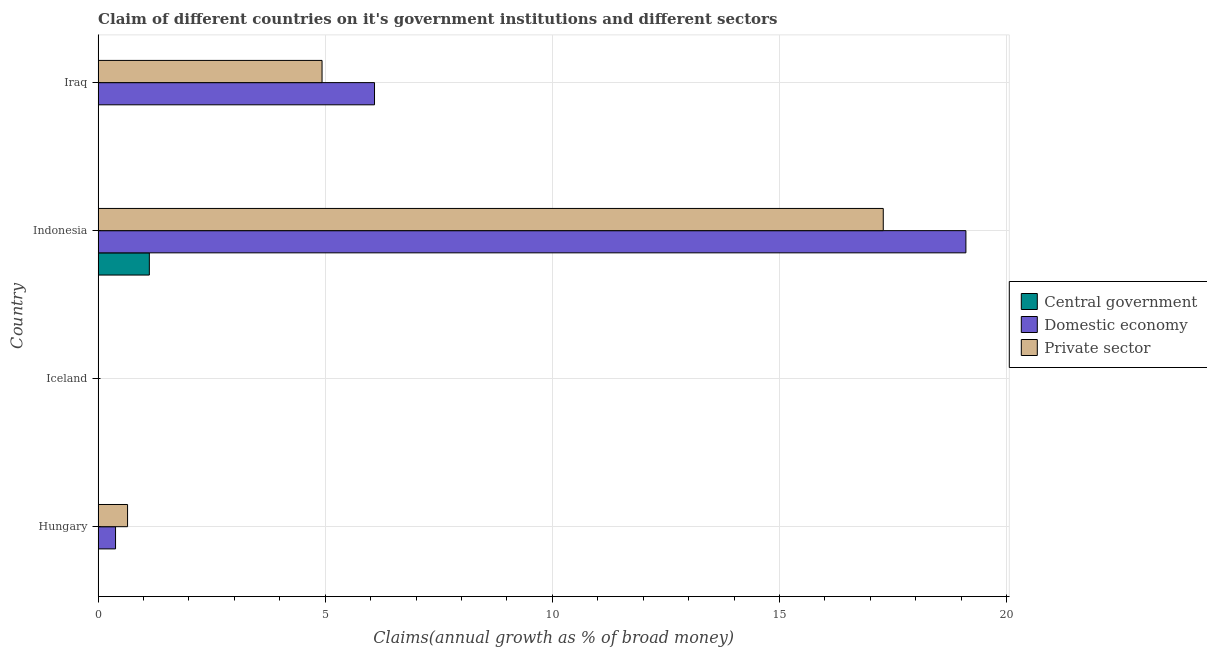Are the number of bars on each tick of the Y-axis equal?
Give a very brief answer. No. How many bars are there on the 4th tick from the top?
Make the answer very short. 2. How many bars are there on the 1st tick from the bottom?
Your answer should be very brief. 2. What is the label of the 4th group of bars from the top?
Keep it short and to the point. Hungary. Across all countries, what is the maximum percentage of claim on the central government?
Provide a short and direct response. 1.13. Across all countries, what is the minimum percentage of claim on the domestic economy?
Ensure brevity in your answer.  0. In which country was the percentage of claim on the private sector maximum?
Make the answer very short. Indonesia. What is the total percentage of claim on the domestic economy in the graph?
Your answer should be very brief. 25.57. What is the difference between the percentage of claim on the domestic economy in Hungary and that in Indonesia?
Your answer should be compact. -18.72. What is the average percentage of claim on the domestic economy per country?
Your response must be concise. 6.39. What is the difference between the percentage of claim on the central government and percentage of claim on the domestic economy in Indonesia?
Offer a terse response. -17.98. What is the ratio of the percentage of claim on the domestic economy in Indonesia to that in Iraq?
Offer a very short reply. 3.14. Is the percentage of claim on the domestic economy in Hungary less than that in Iraq?
Your answer should be very brief. Yes. What is the difference between the highest and the second highest percentage of claim on the private sector?
Offer a very short reply. 12.36. Is the sum of the percentage of claim on the domestic economy in Indonesia and Iraq greater than the maximum percentage of claim on the central government across all countries?
Provide a succinct answer. Yes. How many bars are there?
Your response must be concise. 7. Are all the bars in the graph horizontal?
Keep it short and to the point. Yes. How many countries are there in the graph?
Offer a very short reply. 4. Are the values on the major ticks of X-axis written in scientific E-notation?
Your answer should be very brief. No. How are the legend labels stacked?
Offer a terse response. Vertical. What is the title of the graph?
Offer a terse response. Claim of different countries on it's government institutions and different sectors. What is the label or title of the X-axis?
Your answer should be compact. Claims(annual growth as % of broad money). What is the Claims(annual growth as % of broad money) of Central government in Hungary?
Make the answer very short. 0. What is the Claims(annual growth as % of broad money) of Domestic economy in Hungary?
Your response must be concise. 0.38. What is the Claims(annual growth as % of broad money) of Private sector in Hungary?
Provide a short and direct response. 0.65. What is the Claims(annual growth as % of broad money) of Domestic economy in Iceland?
Your answer should be compact. 0. What is the Claims(annual growth as % of broad money) of Private sector in Iceland?
Ensure brevity in your answer.  0. What is the Claims(annual growth as % of broad money) of Central government in Indonesia?
Your response must be concise. 1.13. What is the Claims(annual growth as % of broad money) in Domestic economy in Indonesia?
Your answer should be compact. 19.1. What is the Claims(annual growth as % of broad money) in Private sector in Indonesia?
Your answer should be very brief. 17.29. What is the Claims(annual growth as % of broad money) in Central government in Iraq?
Your answer should be compact. 0. What is the Claims(annual growth as % of broad money) in Domestic economy in Iraq?
Give a very brief answer. 6.09. What is the Claims(annual growth as % of broad money) of Private sector in Iraq?
Ensure brevity in your answer.  4.93. Across all countries, what is the maximum Claims(annual growth as % of broad money) of Central government?
Your answer should be compact. 1.13. Across all countries, what is the maximum Claims(annual growth as % of broad money) of Domestic economy?
Give a very brief answer. 19.1. Across all countries, what is the maximum Claims(annual growth as % of broad money) of Private sector?
Ensure brevity in your answer.  17.29. Across all countries, what is the minimum Claims(annual growth as % of broad money) of Domestic economy?
Keep it short and to the point. 0. What is the total Claims(annual growth as % of broad money) of Central government in the graph?
Your answer should be very brief. 1.13. What is the total Claims(annual growth as % of broad money) in Domestic economy in the graph?
Give a very brief answer. 25.57. What is the total Claims(annual growth as % of broad money) in Private sector in the graph?
Keep it short and to the point. 22.86. What is the difference between the Claims(annual growth as % of broad money) in Domestic economy in Hungary and that in Indonesia?
Your answer should be very brief. -18.72. What is the difference between the Claims(annual growth as % of broad money) of Private sector in Hungary and that in Indonesia?
Ensure brevity in your answer.  -16.64. What is the difference between the Claims(annual growth as % of broad money) in Domestic economy in Hungary and that in Iraq?
Offer a terse response. -5.7. What is the difference between the Claims(annual growth as % of broad money) in Private sector in Hungary and that in Iraq?
Ensure brevity in your answer.  -4.28. What is the difference between the Claims(annual growth as % of broad money) of Domestic economy in Indonesia and that in Iraq?
Provide a succinct answer. 13.02. What is the difference between the Claims(annual growth as % of broad money) of Private sector in Indonesia and that in Iraq?
Your answer should be very brief. 12.36. What is the difference between the Claims(annual growth as % of broad money) in Domestic economy in Hungary and the Claims(annual growth as % of broad money) in Private sector in Indonesia?
Provide a short and direct response. -16.9. What is the difference between the Claims(annual growth as % of broad money) of Domestic economy in Hungary and the Claims(annual growth as % of broad money) of Private sector in Iraq?
Offer a very short reply. -4.55. What is the difference between the Claims(annual growth as % of broad money) of Central government in Indonesia and the Claims(annual growth as % of broad money) of Domestic economy in Iraq?
Provide a short and direct response. -4.96. What is the difference between the Claims(annual growth as % of broad money) in Central government in Indonesia and the Claims(annual growth as % of broad money) in Private sector in Iraq?
Keep it short and to the point. -3.8. What is the difference between the Claims(annual growth as % of broad money) in Domestic economy in Indonesia and the Claims(annual growth as % of broad money) in Private sector in Iraq?
Make the answer very short. 14.17. What is the average Claims(annual growth as % of broad money) of Central government per country?
Your answer should be compact. 0.28. What is the average Claims(annual growth as % of broad money) of Domestic economy per country?
Your answer should be compact. 6.39. What is the average Claims(annual growth as % of broad money) of Private sector per country?
Your response must be concise. 5.72. What is the difference between the Claims(annual growth as % of broad money) of Domestic economy and Claims(annual growth as % of broad money) of Private sector in Hungary?
Your answer should be very brief. -0.26. What is the difference between the Claims(annual growth as % of broad money) of Central government and Claims(annual growth as % of broad money) of Domestic economy in Indonesia?
Offer a terse response. -17.98. What is the difference between the Claims(annual growth as % of broad money) in Central government and Claims(annual growth as % of broad money) in Private sector in Indonesia?
Your response must be concise. -16.16. What is the difference between the Claims(annual growth as % of broad money) in Domestic economy and Claims(annual growth as % of broad money) in Private sector in Indonesia?
Your response must be concise. 1.82. What is the difference between the Claims(annual growth as % of broad money) of Domestic economy and Claims(annual growth as % of broad money) of Private sector in Iraq?
Ensure brevity in your answer.  1.16. What is the ratio of the Claims(annual growth as % of broad money) in Domestic economy in Hungary to that in Indonesia?
Offer a very short reply. 0.02. What is the ratio of the Claims(annual growth as % of broad money) of Private sector in Hungary to that in Indonesia?
Offer a very short reply. 0.04. What is the ratio of the Claims(annual growth as % of broad money) of Domestic economy in Hungary to that in Iraq?
Ensure brevity in your answer.  0.06. What is the ratio of the Claims(annual growth as % of broad money) of Private sector in Hungary to that in Iraq?
Keep it short and to the point. 0.13. What is the ratio of the Claims(annual growth as % of broad money) in Domestic economy in Indonesia to that in Iraq?
Keep it short and to the point. 3.14. What is the ratio of the Claims(annual growth as % of broad money) in Private sector in Indonesia to that in Iraq?
Your answer should be very brief. 3.51. What is the difference between the highest and the second highest Claims(annual growth as % of broad money) of Domestic economy?
Give a very brief answer. 13.02. What is the difference between the highest and the second highest Claims(annual growth as % of broad money) in Private sector?
Offer a terse response. 12.36. What is the difference between the highest and the lowest Claims(annual growth as % of broad money) of Central government?
Keep it short and to the point. 1.13. What is the difference between the highest and the lowest Claims(annual growth as % of broad money) in Domestic economy?
Give a very brief answer. 19.11. What is the difference between the highest and the lowest Claims(annual growth as % of broad money) of Private sector?
Your response must be concise. 17.29. 